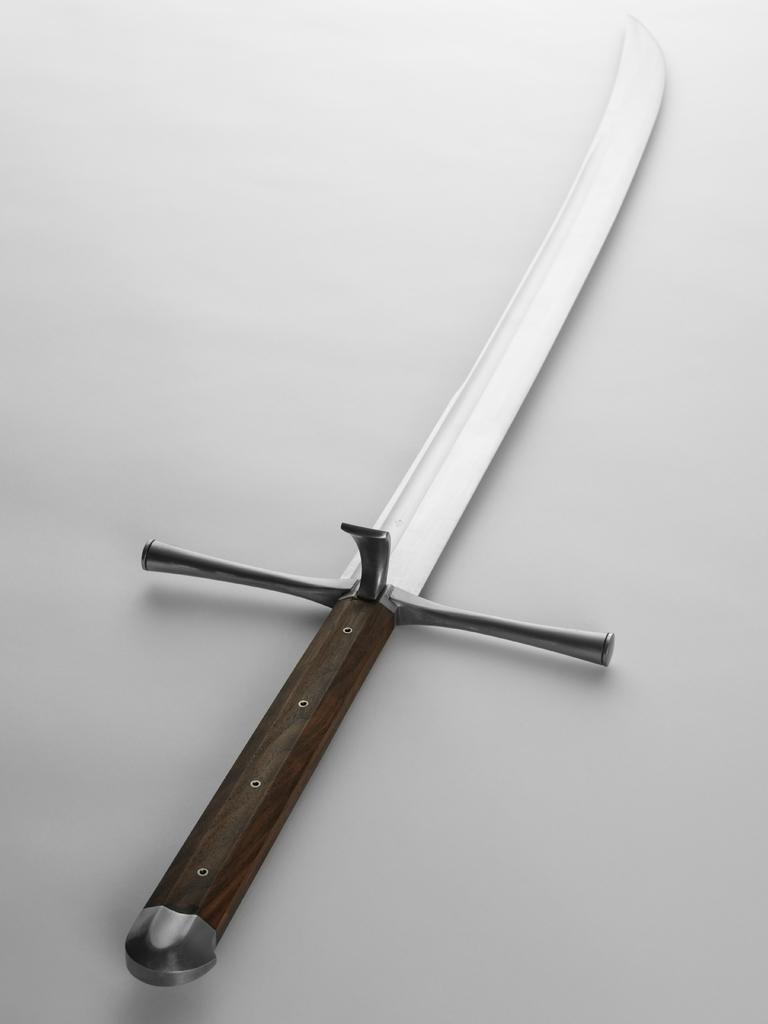Please provide a concise description of this image. In this image I can see a knife and background is white. 